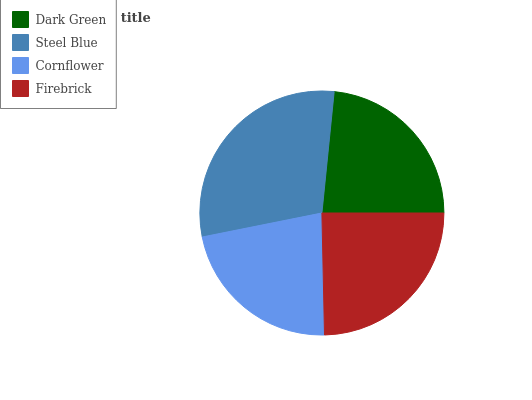Is Cornflower the minimum?
Answer yes or no. Yes. Is Steel Blue the maximum?
Answer yes or no. Yes. Is Steel Blue the minimum?
Answer yes or no. No. Is Cornflower the maximum?
Answer yes or no. No. Is Steel Blue greater than Cornflower?
Answer yes or no. Yes. Is Cornflower less than Steel Blue?
Answer yes or no. Yes. Is Cornflower greater than Steel Blue?
Answer yes or no. No. Is Steel Blue less than Cornflower?
Answer yes or no. No. Is Firebrick the high median?
Answer yes or no. Yes. Is Dark Green the low median?
Answer yes or no. Yes. Is Steel Blue the high median?
Answer yes or no. No. Is Steel Blue the low median?
Answer yes or no. No. 